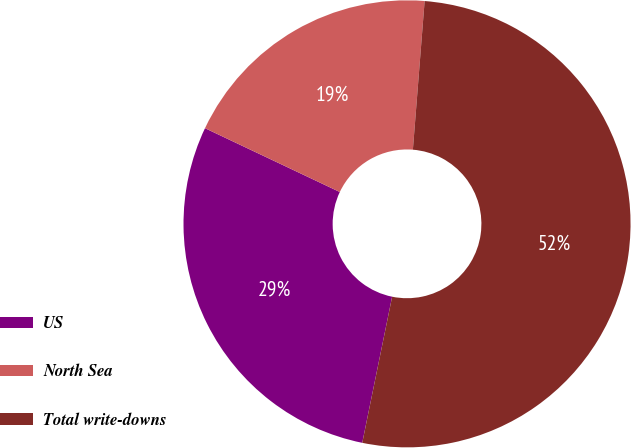Convert chart. <chart><loc_0><loc_0><loc_500><loc_500><pie_chart><fcel>US<fcel>North Sea<fcel>Total write-downs<nl><fcel>28.83%<fcel>19.22%<fcel>51.96%<nl></chart> 